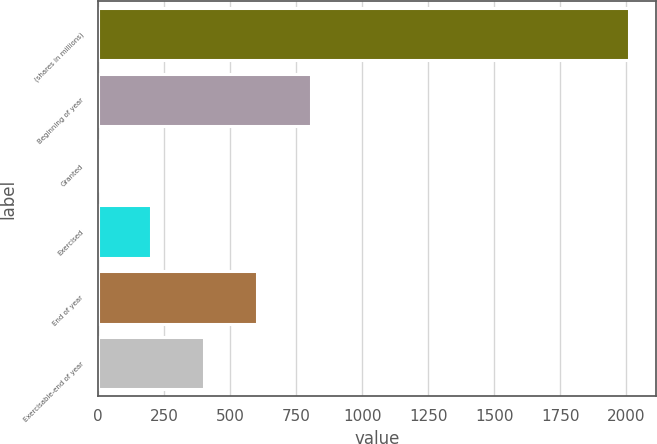Convert chart. <chart><loc_0><loc_0><loc_500><loc_500><bar_chart><fcel>(shares in millions)<fcel>Beginning of year<fcel>Granted<fcel>Exercised<fcel>End of year<fcel>Exercisable-end of year<nl><fcel>2010<fcel>804.6<fcel>1<fcel>201.9<fcel>603.7<fcel>402.8<nl></chart> 